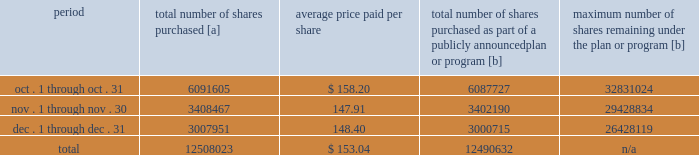Purchases of equity securities 2013 during 2018 , we repurchased 57669746 shares of our common stock at an average price of $ 143.70 .
The table presents common stock repurchases during each month for the fourth quarter of 2018 : period total number of shares purchased [a] average price paid per share total number of shares purchased as part of a publicly announced plan or program [b] maximum number of shares remaining under the plan or program [b] .
[a] total number of shares purchased during the quarter includes approximately 17391 shares delivered or attested to upc by employees to pay stock option exercise prices , satisfy excess tax withholding obligations for stock option exercises or vesting of retention units , and pay withholding obligations for vesting of retention shares .
[b] effective january 1 , 2017 , our board of directors authorized the repurchase of up to 120 million shares of our common stock by december 31 , 2020 .
These repurchases may be made on the open market or through other transactions .
Our management has sole discretion with respect to determining the timing and amount of these transactions. .
What percentage of the total number of shares purchased where purchased in december? 
Computations: (3007951 / 12508023)
Answer: 0.24048. 